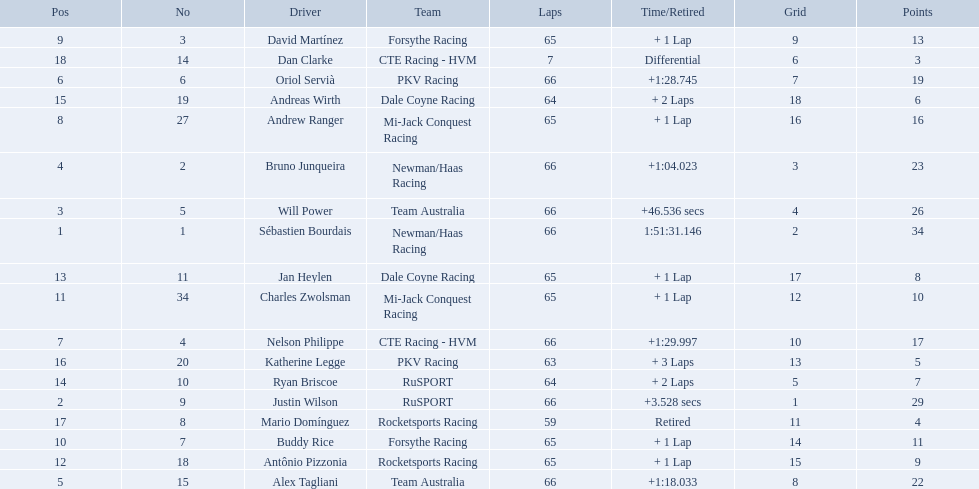Who are all of the 2006 gran premio telmex drivers? Sébastien Bourdais, Justin Wilson, Will Power, Bruno Junqueira, Alex Tagliani, Oriol Servià, Nelson Philippe, Andrew Ranger, David Martínez, Buddy Rice, Charles Zwolsman, Antônio Pizzonia, Jan Heylen, Ryan Briscoe, Andreas Wirth, Katherine Legge, Mario Domínguez, Dan Clarke. How many laps did they finish? 66, 66, 66, 66, 66, 66, 66, 65, 65, 65, 65, 65, 65, 64, 64, 63, 59, 7. What about just oriol servia and katherine legge? 66, 63. And which of those two drivers finished more laps? Oriol Servià. Who are the drivers? Sébastien Bourdais, Justin Wilson, Will Power, Bruno Junqueira, Alex Tagliani, Oriol Servià, Nelson Philippe, Andrew Ranger, David Martínez, Buddy Rice, Charles Zwolsman, Antônio Pizzonia, Jan Heylen, Ryan Briscoe, Andreas Wirth, Katherine Legge, Mario Domínguez, Dan Clarke. What are their numbers? 1, 9, 5, 2, 15, 6, 4, 27, 3, 7, 34, 18, 11, 10, 19, 20, 8, 14. What are their positions? 1, 2, 3, 4, 5, 6, 7, 8, 9, 10, 11, 12, 13, 14, 15, 16, 17, 18. Which driver has the same number and position? Sébastien Bourdais. What drivers started in the top 10? Sébastien Bourdais, Justin Wilson, Will Power, Bruno Junqueira, Alex Tagliani, Oriol Servià, Nelson Philippe, Ryan Briscoe, Dan Clarke. Which of those drivers completed all 66 laps? Sébastien Bourdais, Justin Wilson, Will Power, Bruno Junqueira, Alex Tagliani, Oriol Servià, Nelson Philippe. Whom of these did not drive for team australia? Sébastien Bourdais, Justin Wilson, Bruno Junqueira, Oriol Servià, Nelson Philippe. Which of these drivers finished more then a minuet after the winner? Bruno Junqueira, Oriol Servià, Nelson Philippe. Which of these drivers had the highest car number? Oriol Servià. What are the drivers numbers? 1, 9, 5, 2, 15, 6, 4, 27, 3, 7, 34, 18, 11, 10, 19, 20, 8, 14. Are there any who's number matches his position? Sébastien Bourdais, Oriol Servià. Of those two who has the highest position? Sébastien Bourdais. 